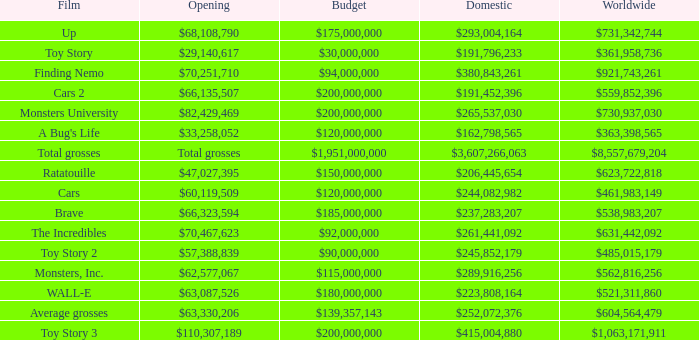WHAT IS THE OPENING WITH A WORLDWIDE NUMBER OF $559,852,396? $66,135,507. 